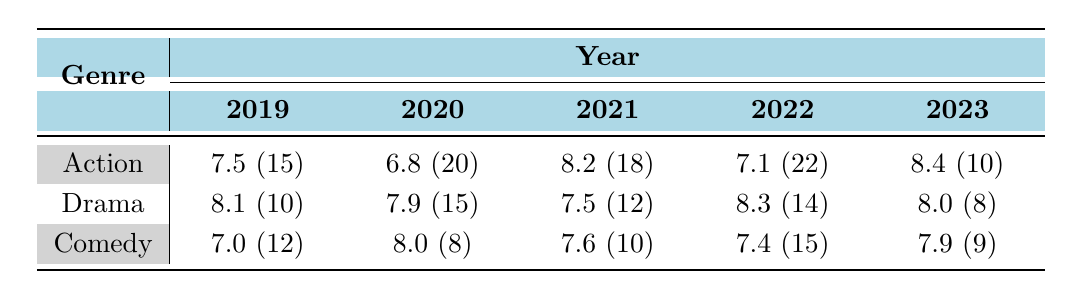What is the average rating for Action films in 2021? According to the table, the average rating for Action films in 2021 is listed as 8.2.
Answer: 8.2 How many Drama films were released in 2022? The table indicates that there were 14 Drama films released in 2022.
Answer: 14 Which genre had the highest average rating in 2020? In 2020, the average ratings for each genre are: Action 6.8, Drama 7.9, Comedy 8.0. The highest average rating is from Comedy at 8.0.
Answer: Comedy Did the average rating for Action films improve from 2019 to 2023? The average ratings for Action films are as follows: 2019: 7.5, 2023: 8.4. Since 8.4 is greater than 7.5, the average rating improved.
Answer: Yes What is the total number of Comedy films released from 2019 to 2022? The total number of Comedy films are: 2019: 12, 2020: 8, 2021: 10, 2022: 15. Adding these gives a total of 12 + 8 + 10 + 15 = 45 Comedy films.
Answer: 45 Which year had the lowest average rating for Action films? The average ratings are: 2019: 7.5, 2020: 6.8, 2021: 8.2, 2022: 7.1, 2023: 8.4. The lowest is 6.8 in 2020.
Answer: 2020 Are there more Drama films or Comedy films released in 2023? The table shows 8 Drama films and 9 Comedy films released in 2023. Since 9 is greater than 8, Comedy films are more numerous.
Answer: Comedy What is the difference in average ratings for Drama films between 2020 and 2021? The average ratings are: Drama 2020: 7.9, Drama 2021: 7.5. The difference is 7.9 - 7.5 = 0.4.
Answer: 0.4 